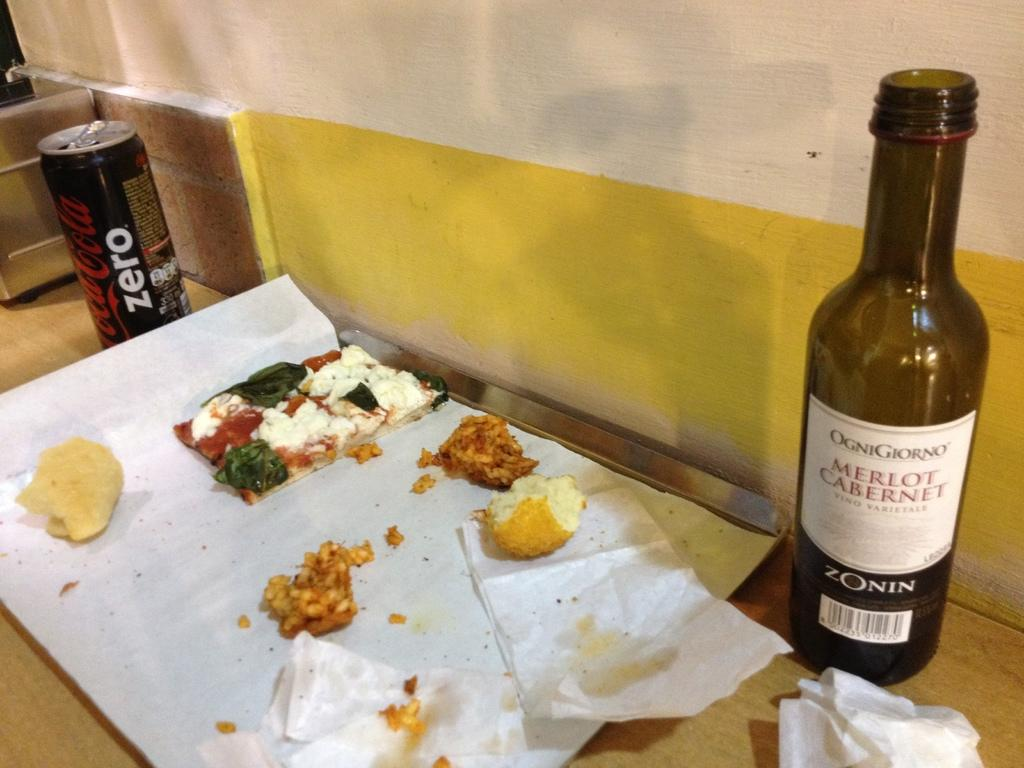<image>
Offer a succinct explanation of the picture presented. A bottle of Merlot is next to the remnants of a meal. 